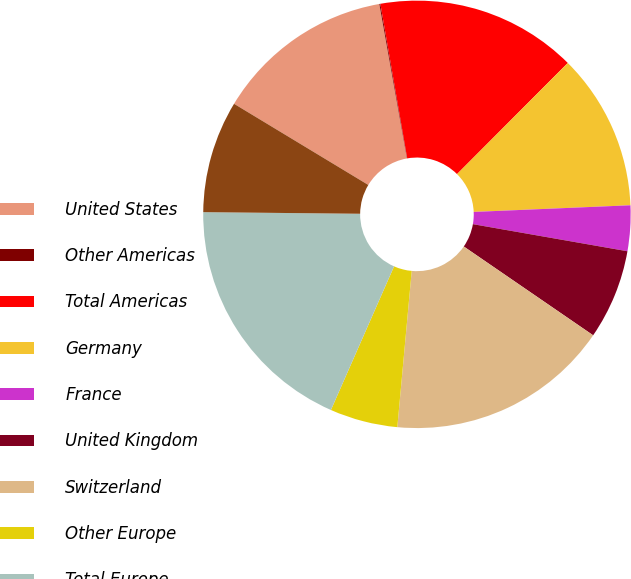<chart> <loc_0><loc_0><loc_500><loc_500><pie_chart><fcel>United States<fcel>Other Americas<fcel>Total Americas<fcel>Germany<fcel>France<fcel>United Kingdom<fcel>Switzerland<fcel>Other Europe<fcel>Total Europe<fcel>China<nl><fcel>13.53%<fcel>0.08%<fcel>15.21%<fcel>11.85%<fcel>3.44%<fcel>6.81%<fcel>16.89%<fcel>5.13%<fcel>18.57%<fcel>8.49%<nl></chart> 